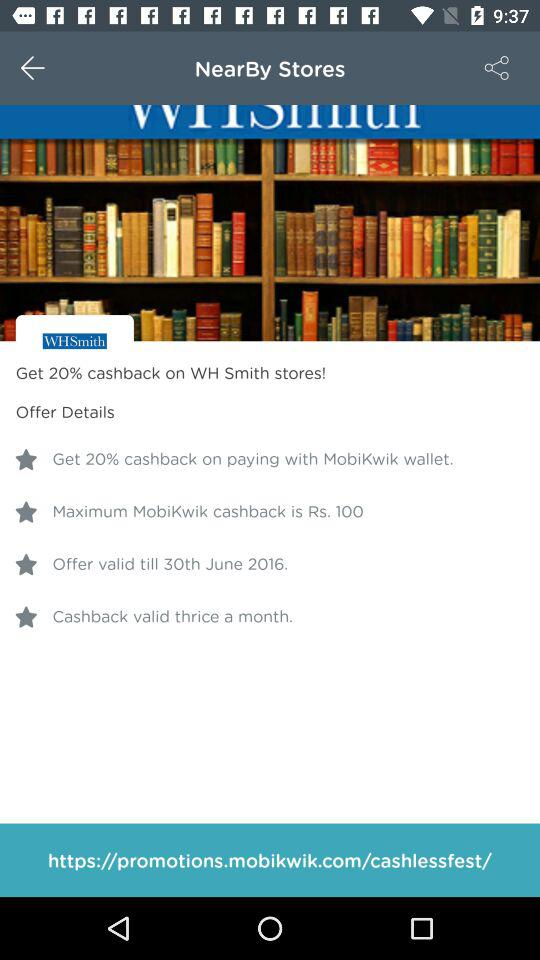What's the percentage of cashback? The cashback is 20%. 